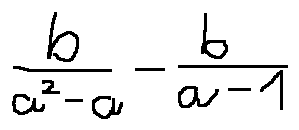<formula> <loc_0><loc_0><loc_500><loc_500>\frac { b } { a ^ { 2 } - a } - \frac { b } { a - 1 }</formula> 